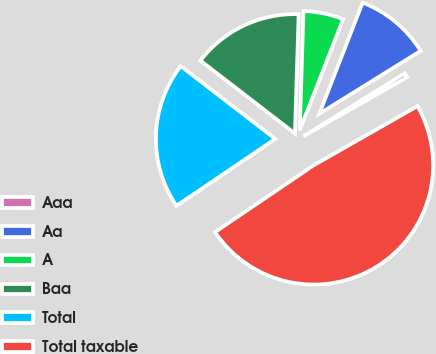<chart> <loc_0><loc_0><loc_500><loc_500><pie_chart><fcel>Aaa<fcel>Aa<fcel>A<fcel>Baa<fcel>Total<fcel>Total taxable<nl><fcel>0.6%<fcel>10.24%<fcel>5.42%<fcel>15.05%<fcel>19.92%<fcel>48.77%<nl></chart> 